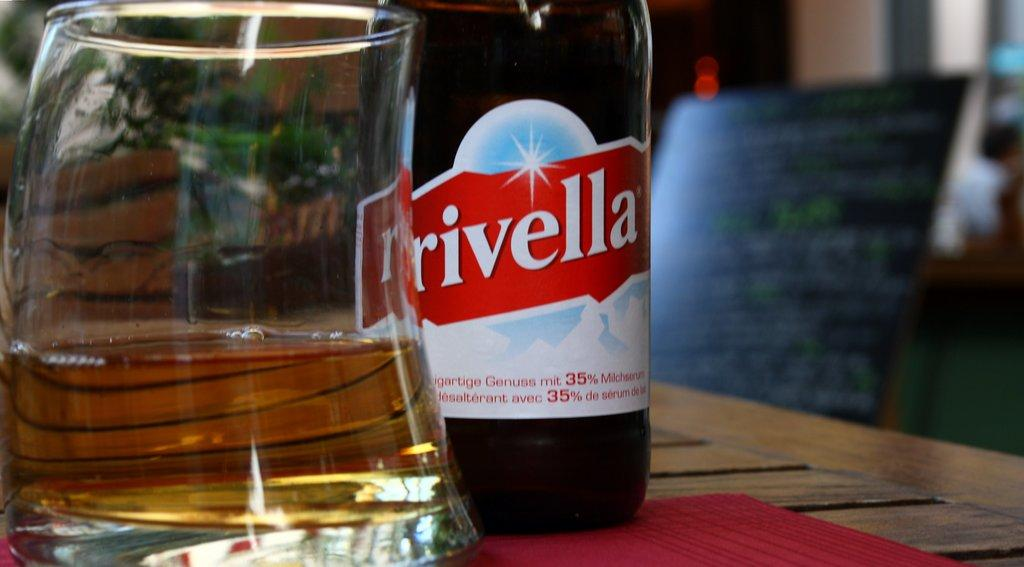<image>
Summarize the visual content of the image. Rivella product that is poured into a glass that is on a tabletop. 